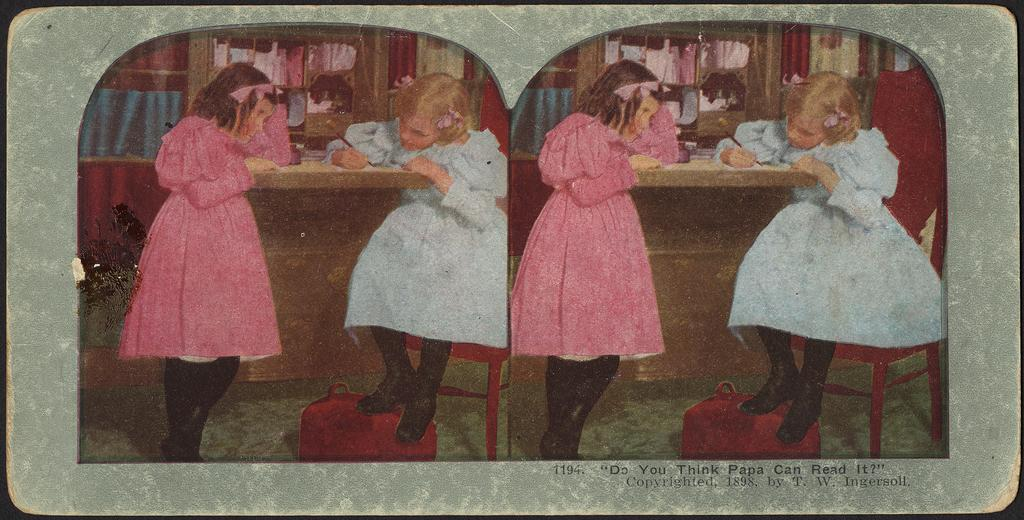What can be seen in the image that appears twice? There are two identical pictures in the image. How many people are present in the image? There are two people in the image. What is one person doing in the image? One person is holding something. Where is the person holding something located? The person holding something is sitting on a chair. What can be seen in the background of the image? There is a cupboard with objects visible in the background. What type of transport is visible in the image? There is no transport visible in the image. What company is associated with the objects in the cupboard? The image does not provide information about any company associated with the objects in the cupboard. 